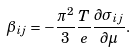Convert formula to latex. <formula><loc_0><loc_0><loc_500><loc_500>\beta _ { i j } = - \frac { \pi ^ { 2 } } { 3 } \frac { T } { e } \frac { \partial \sigma _ { i j } } { \partial \mu } .</formula> 